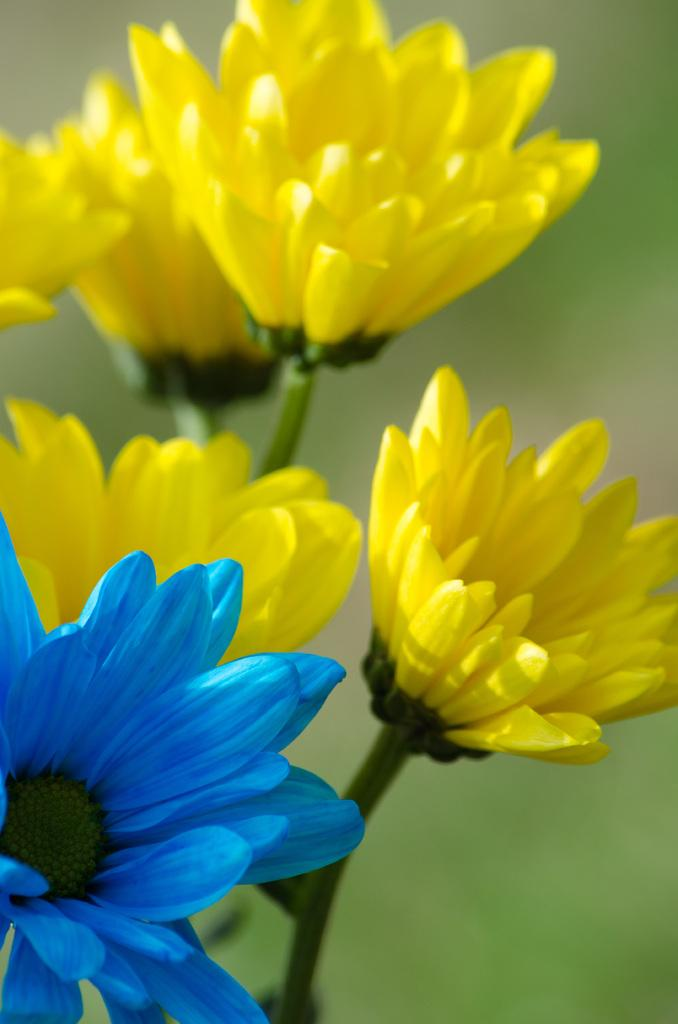What type of objects are present in the image? There are flowers in the image. What colors can be seen in the flowers? The flowers are in yellow and blue colors. What type of flower do the objects resemble? The flowers resemble sunflowers. How would you describe the background of the image? The background of the image is blurred. How many chairs are placed around the flowers in the image? There are no chairs present in the image; it only features flowers. What type of pigs can be seen interacting with the flowers in the image? There are no pigs present in the image; it only features flowers. 